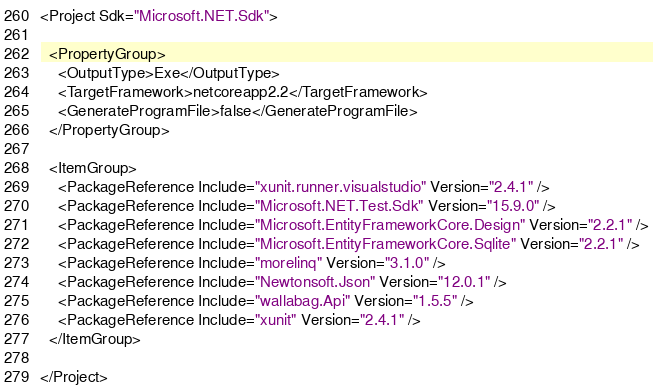Convert code to text. <code><loc_0><loc_0><loc_500><loc_500><_XML_><Project Sdk="Microsoft.NET.Sdk">

  <PropertyGroup>
    <OutputType>Exe</OutputType>
    <TargetFramework>netcoreapp2.2</TargetFramework>
    <GenerateProgramFile>false</GenerateProgramFile>
  </PropertyGroup>

  <ItemGroup>
    <PackageReference Include="xunit.runner.visualstudio" Version="2.4.1" />
    <PackageReference Include="Microsoft.NET.Test.Sdk" Version="15.9.0" />
    <PackageReference Include="Microsoft.EntityFrameworkCore.Design" Version="2.2.1" />
    <PackageReference Include="Microsoft.EntityFrameworkCore.Sqlite" Version="2.2.1" />
    <PackageReference Include="morelinq" Version="3.1.0" />
    <PackageReference Include="Newtonsoft.Json" Version="12.0.1" />
    <PackageReference Include="wallabag.Api" Version="1.5.5" />
    <PackageReference Include="xunit" Version="2.4.1" />
  </ItemGroup>

</Project>
</code> 